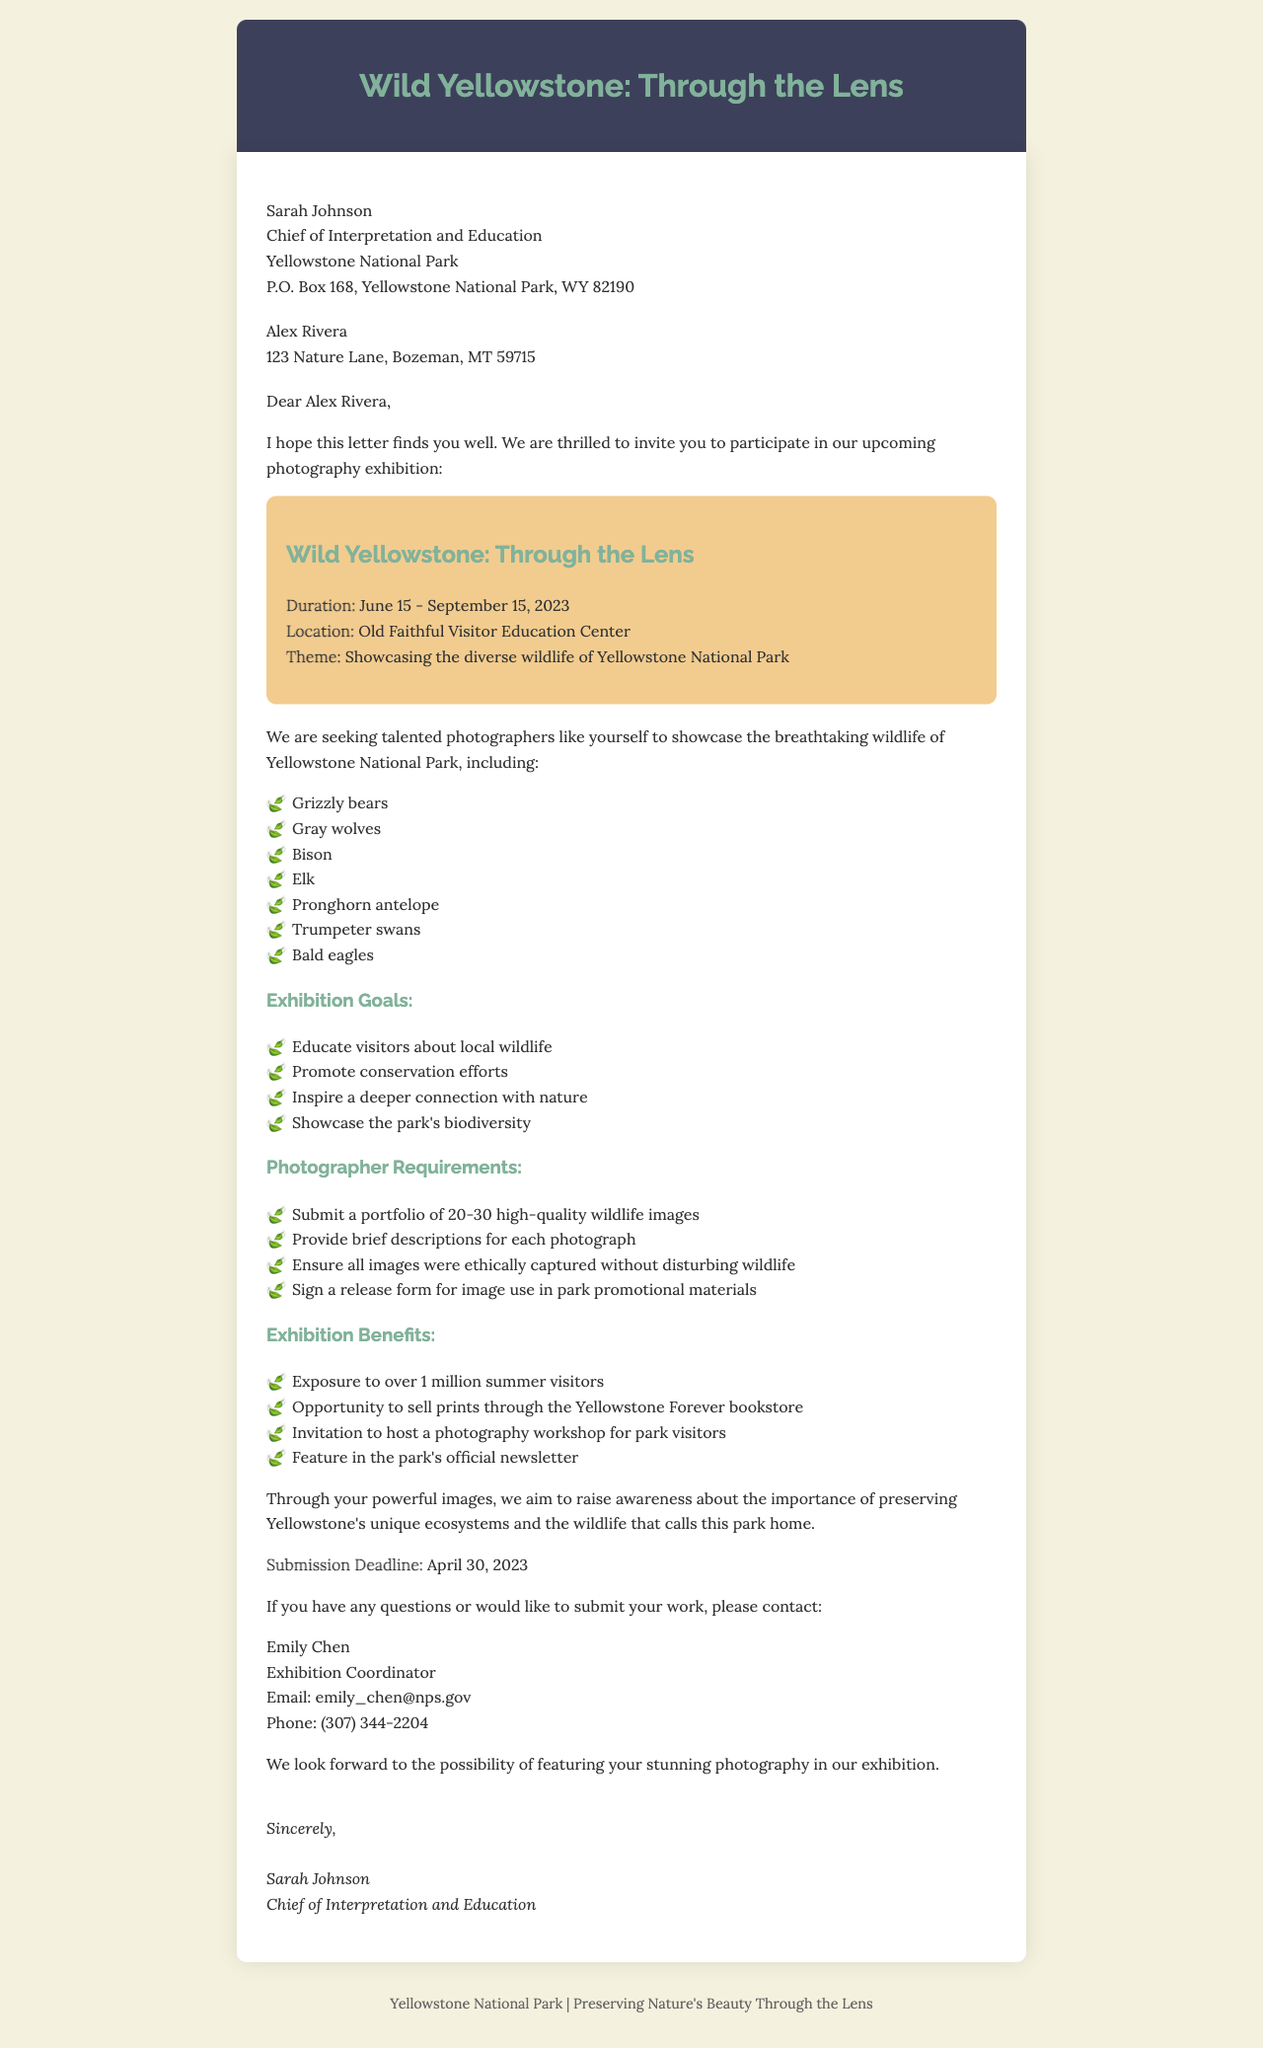What is the title of the exhibition? The title of the exhibition is prominently mentioned in the document.
Answer: Wild Yellowstone: Through the Lens What is the start date of the exhibition? The start date of the exhibition is part of the exhibition details section.
Answer: June 15, 2023 How long will the exhibition run? The duration of the exhibition is specified in the document, indicating the end date as well.
Answer: Three months Who is the sender of the letter? The sender's information is clearly listed at the beginning of the document.
Answer: Sarah Johnson What wildlife subjects will be showcased? The document lists specific wildlife subjects that will be included in the exhibition.
Answer: Grizzly bears, Gray wolves, Bison, Elk, Pronghorn antelope, Trumpeter swans, Bald eagles What is one of the exhibition goals? One of the goals is mentioned among several listed objectives in the document.
Answer: Inspire a deeper connection with nature What is the submission deadline for photographers? The submission deadline is explicitly stated in the letter.
Answer: April 30, 2023 What benefit includes selling prints? The benefits section outlines various advantages, including one that refers to selling prints.
Answer: Opportunity to sell prints through the Yellowstone Forever bookstore Who should be contacted for questions? Contact information for inquiries is provided towards the end of the letter.
Answer: Emily Chen 